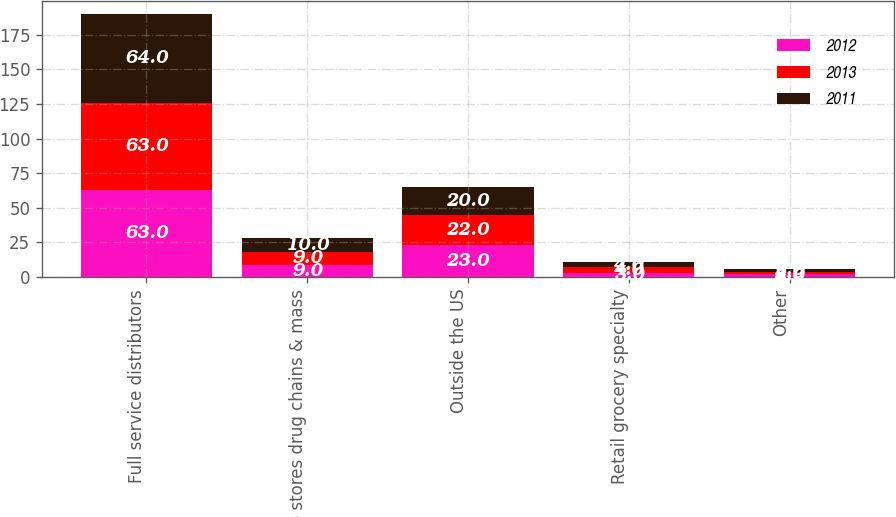Convert chart to OTSL. <chart><loc_0><loc_0><loc_500><loc_500><stacked_bar_chart><ecel><fcel>Full service distributors<fcel>Club stores drug chains & mass<fcel>Outside the US<fcel>Retail grocery specialty<fcel>Other<nl><fcel>2012<fcel>63<fcel>9<fcel>23<fcel>3<fcel>2<nl><fcel>2013<fcel>63<fcel>9<fcel>22<fcel>4<fcel>2<nl><fcel>2011<fcel>64<fcel>10<fcel>20<fcel>4<fcel>2<nl></chart> 